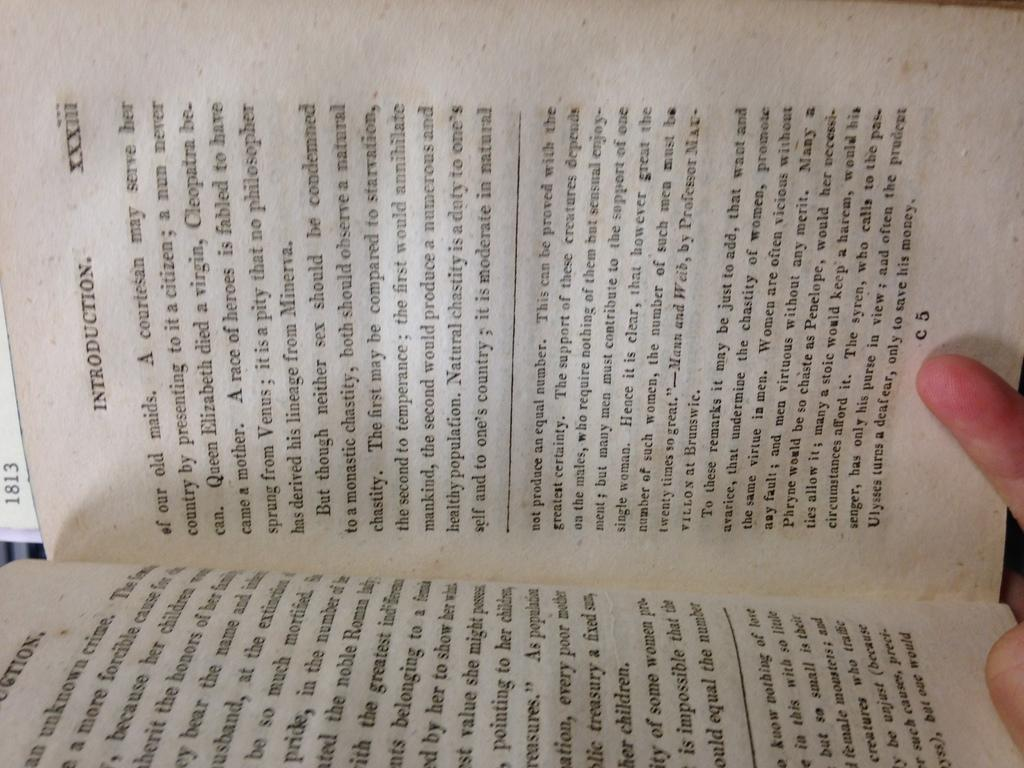<image>
Describe the image concisely. The introduction page of a typed book shown on page C5. 